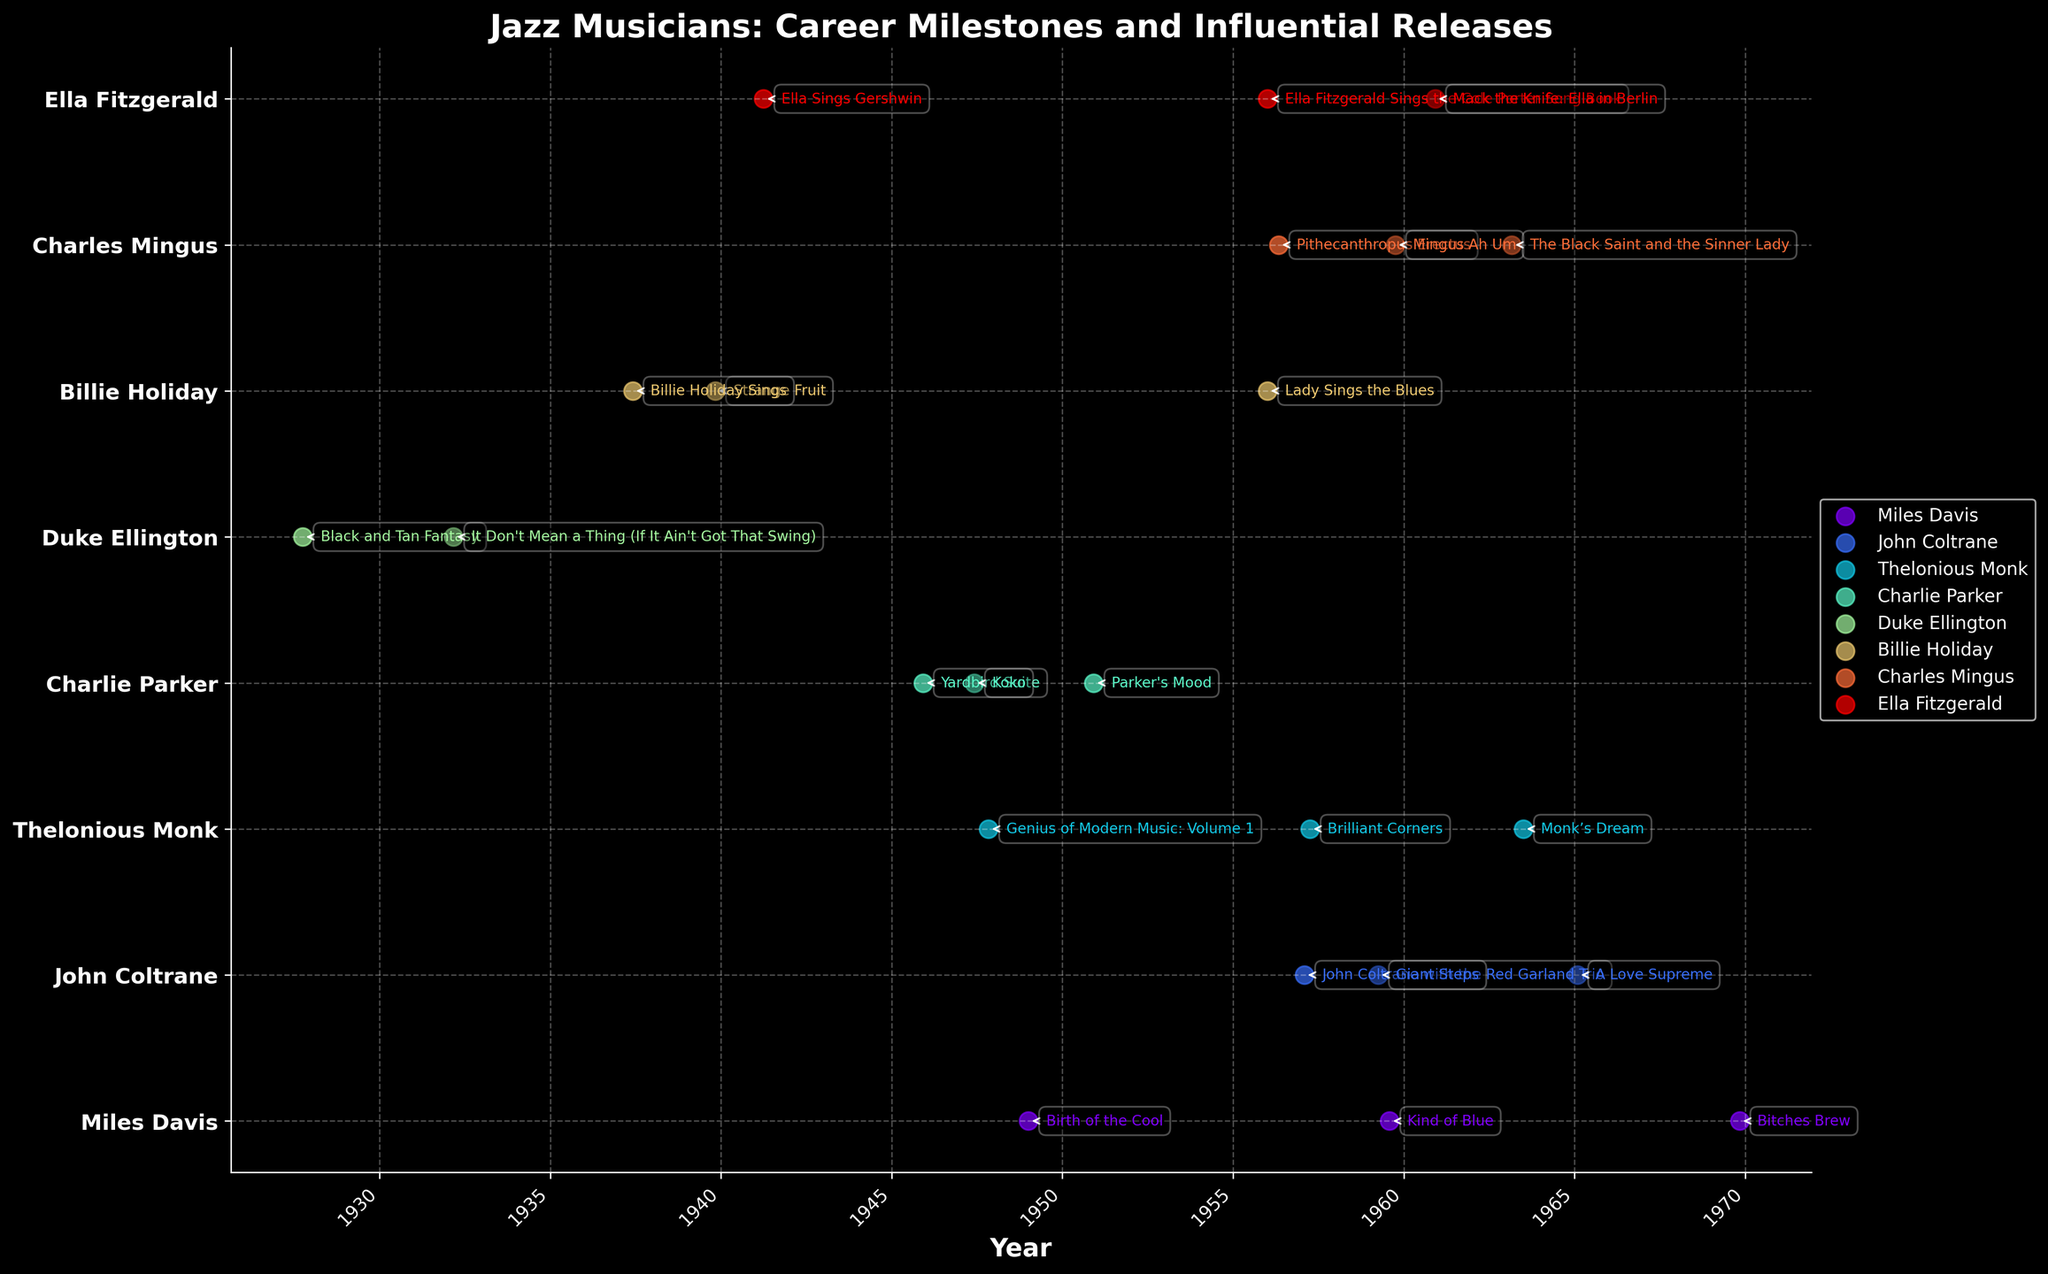Which musician has the earliest debut album in your jazz career timeline? By looking at the earliest date among the "Debut Album" events, Duke Ellington's album "Black and Tan Fantasy" in October 1927 is the first on the timeline.
Answer: Duke Ellington How many influential releases does Miles Davis have according to the plot? Count the number of "Influential Release" events for Miles Davis. These are three: "Kind of Blue" (1959), "Bitches Brew" (1969), and "Birth of the Cool" (1949).
Answer: 3 What are the titles of John Coltrane's influential releases and when were they released? Identify the "Influential Release" events for John Coltrane from the plot, which are "Giant Steps" in April 1959 and "A Love Supreme" in February 1965.
Answer: "Giant Steps" (1959), "A Love Supreme" (1965) Which musician has the most influential releases, and how many do they have according to this plot? Compare the number of "Influential Release" events for each musician. Charlie Parker has three influential releases: "Yardbird Suite" (1945), "Koko" (1947), and "Parker's Mood" (1950).
Answer: Charlie Parker, 3 Among Charlie Parker's influential releases, which one was released first? Identify and compare the dates of Charlie Parker's "Influential Release" events. "Yardbird Suite," released in December 1945, is the earliest.
Answer: "Yardbird Suite" What can be observed regarding the debut album and influential releases of Billie Holiday? By examining the plot, Billie Holiday's debut album "Billie Holiday Sings" was released in June 1937. Her influential releases include "Strange Fruit" in November 1939 and "Lady Sings the Blues" in January 1956.
Answer: "Billie Holiday Sings" (1937), "Strange Fruit" (1939), "Lady Sings the Blues" (1956) Which musician released their influential work "The Black Saint and the Sinner Lady" and in what year? The plot shows that Charles Mingus released "The Black Saint and the Sinner Lady" in March 1963.
Answer: Charles Mingus, 1963 Which two musicians had influential releases in the 1950s and what are the titles of their releases? Analyze the plot for "Influential Release" events within the 1950s. Miles Davis released "Kind of Blue" in 1959, and John Coltrane released "Giant Steps" also in 1959.
Answer: Miles Davis ("Kind of Blue"), John Coltrane ("Giant Steps") Did any musician have their debut album and an influential release in the same year? If yes, specify the musician and the albums. By checking the plot, no musician had both a debut album and an influential release in the same year.
Answer: No 